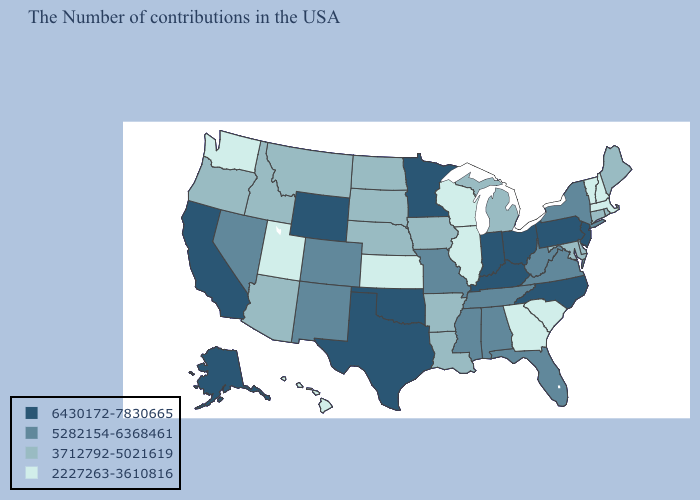Name the states that have a value in the range 3712792-5021619?
Keep it brief. Maine, Rhode Island, Connecticut, Delaware, Maryland, Michigan, Louisiana, Arkansas, Iowa, Nebraska, South Dakota, North Dakota, Montana, Arizona, Idaho, Oregon. What is the lowest value in states that border Texas?
Answer briefly. 3712792-5021619. Name the states that have a value in the range 2227263-3610816?
Be succinct. Massachusetts, New Hampshire, Vermont, South Carolina, Georgia, Wisconsin, Illinois, Kansas, Utah, Washington, Hawaii. Name the states that have a value in the range 2227263-3610816?
Short answer required. Massachusetts, New Hampshire, Vermont, South Carolina, Georgia, Wisconsin, Illinois, Kansas, Utah, Washington, Hawaii. What is the value of West Virginia?
Concise answer only. 5282154-6368461. What is the lowest value in the USA?
Quick response, please. 2227263-3610816. Among the states that border Florida , which have the highest value?
Concise answer only. Alabama. What is the lowest value in the USA?
Be succinct. 2227263-3610816. Does Alaska have the highest value in the USA?
Concise answer only. Yes. Name the states that have a value in the range 2227263-3610816?
Short answer required. Massachusetts, New Hampshire, Vermont, South Carolina, Georgia, Wisconsin, Illinois, Kansas, Utah, Washington, Hawaii. What is the highest value in states that border Delaware?
Answer briefly. 6430172-7830665. Does New Mexico have a lower value than Alabama?
Quick response, please. No. What is the lowest value in the South?
Quick response, please. 2227263-3610816. What is the lowest value in the Northeast?
Quick response, please. 2227263-3610816. Among the states that border Washington , which have the highest value?
Give a very brief answer. Idaho, Oregon. 